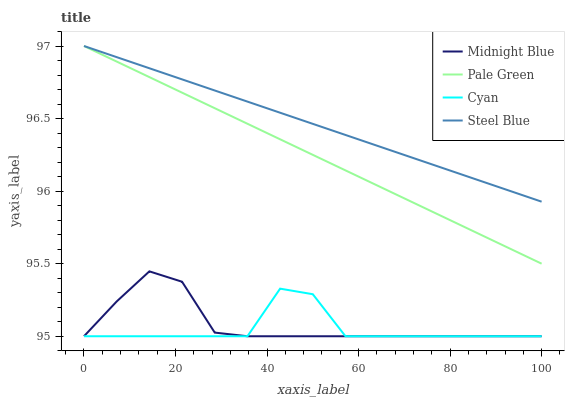Does Cyan have the minimum area under the curve?
Answer yes or no. Yes. Does Steel Blue have the maximum area under the curve?
Answer yes or no. Yes. Does Pale Green have the minimum area under the curve?
Answer yes or no. No. Does Pale Green have the maximum area under the curve?
Answer yes or no. No. Is Steel Blue the smoothest?
Answer yes or no. Yes. Is Cyan the roughest?
Answer yes or no. Yes. Is Pale Green the smoothest?
Answer yes or no. No. Is Pale Green the roughest?
Answer yes or no. No. Does Pale Green have the lowest value?
Answer yes or no. No. Does Steel Blue have the highest value?
Answer yes or no. Yes. Does Midnight Blue have the highest value?
Answer yes or no. No. Is Midnight Blue less than Pale Green?
Answer yes or no. Yes. Is Steel Blue greater than Cyan?
Answer yes or no. Yes. Does Cyan intersect Midnight Blue?
Answer yes or no. Yes. Is Cyan less than Midnight Blue?
Answer yes or no. No. Is Cyan greater than Midnight Blue?
Answer yes or no. No. Does Midnight Blue intersect Pale Green?
Answer yes or no. No. 